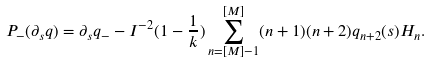Convert formula to latex. <formula><loc_0><loc_0><loc_500><loc_500>P _ { - } ( \partial _ { s } q ) = \partial _ { s } q _ { - } - I ^ { - 2 } ( 1 - \frac { 1 } { k } ) \sum _ { n = [ M ] - 1 } ^ { [ M ] } ( n + 1 ) ( n + 2 ) q _ { n + 2 } ( s ) H _ { n } .</formula> 